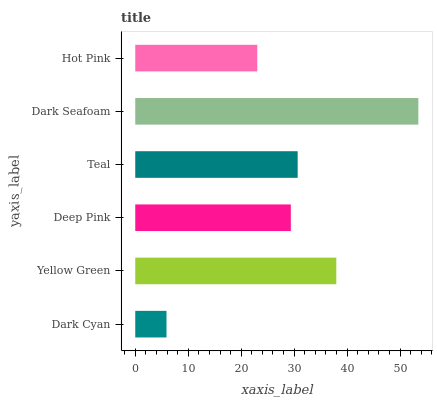Is Dark Cyan the minimum?
Answer yes or no. Yes. Is Dark Seafoam the maximum?
Answer yes or no. Yes. Is Yellow Green the minimum?
Answer yes or no. No. Is Yellow Green the maximum?
Answer yes or no. No. Is Yellow Green greater than Dark Cyan?
Answer yes or no. Yes. Is Dark Cyan less than Yellow Green?
Answer yes or no. Yes. Is Dark Cyan greater than Yellow Green?
Answer yes or no. No. Is Yellow Green less than Dark Cyan?
Answer yes or no. No. Is Teal the high median?
Answer yes or no. Yes. Is Deep Pink the low median?
Answer yes or no. Yes. Is Hot Pink the high median?
Answer yes or no. No. Is Teal the low median?
Answer yes or no. No. 